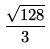<formula> <loc_0><loc_0><loc_500><loc_500>\frac { \sqrt { 1 2 8 } } { 3 }</formula> 